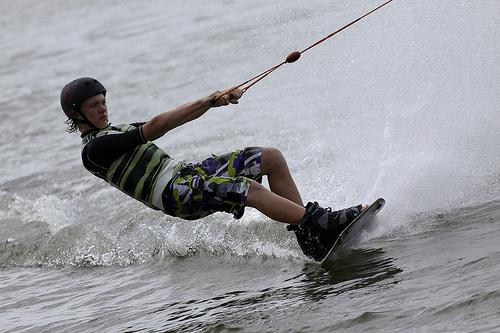Question: what is the man doing?
Choices:
A. Water skiing.
B. Dancing.
C. Skating.
D. Driving.
Answer with the letter. Answer: A Question: when was this picture taken?
Choices:
A. Night time.
B. Daytime.
C. Morning.
D. Evening.
Answer with the letter. Answer: B Question: where was this picture taken?
Choices:
A. The park.
B. The ocean.
C. The backyard.
D. The lake.
Answer with the letter. Answer: B Question: what color is the man's shirt?
Choices:
A. White.
B. Black.
C. Blue.
D. Yellow and blue.
Answer with the letter. Answer: D Question: who is in the picture?
Choices:
A. A woman.
B. A boy.
C. A girl.
D. A man.
Answer with the letter. Answer: D Question: how is the water?
Choices:
A. Tepid.
B. Choppy.
C. Stagnant.
D. Raging.
Answer with the letter. Answer: B 